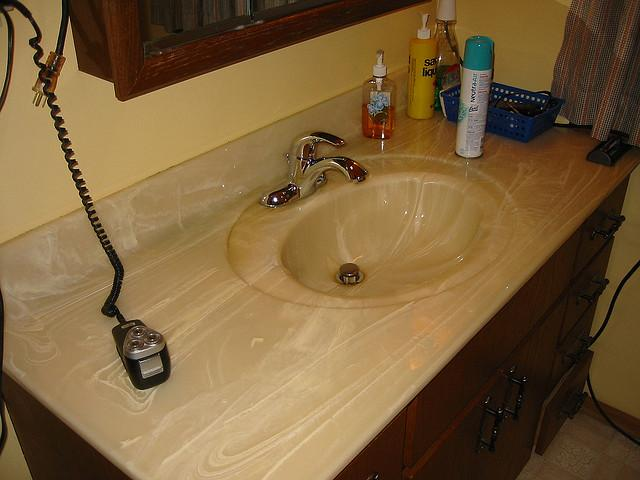What is the corded object called? Please explain your reasoning. electric razor. There is a corded razor on the counter. 